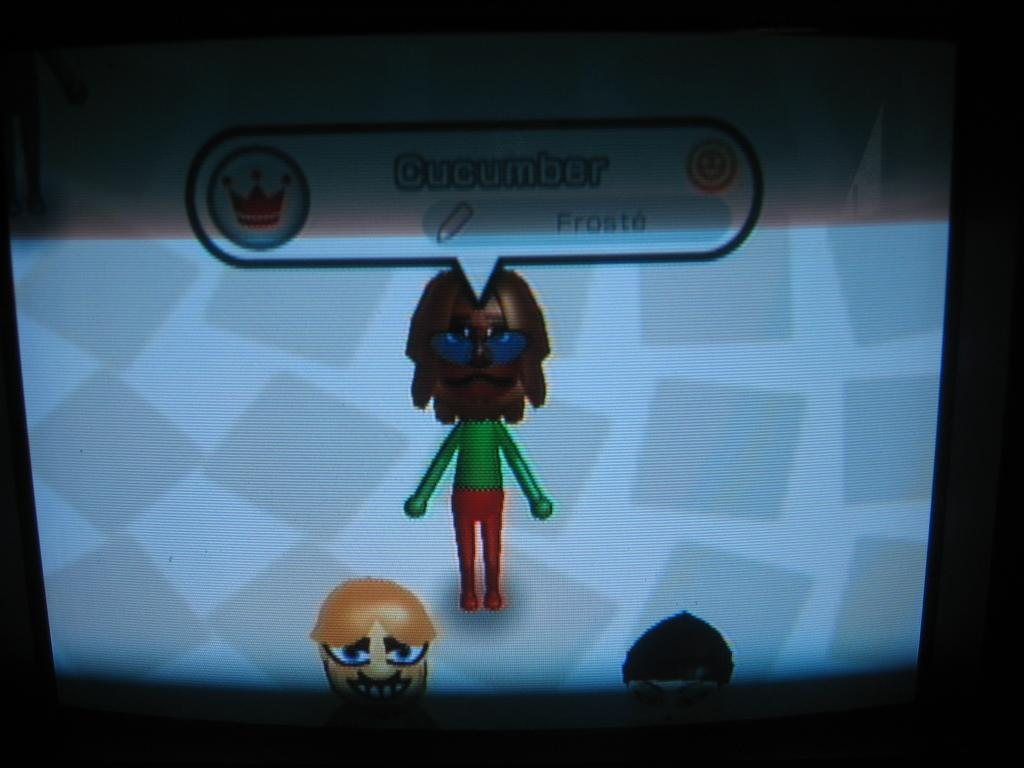What is the main object in the center of the image? There is a television in the center of the image. What is being displayed on the television? The television is displaying an animation. Can you describe the animation? The animation features persons. What is written at the top of the image? There is text written at the top of the image. What type of toy can be seen being used by the persons in the animation? There is no toy visible in the animation; it only features persons. Can you tell me when the birth of the persons in the animation occurred? The image does not provide information about the birth of the persons in the animation. 